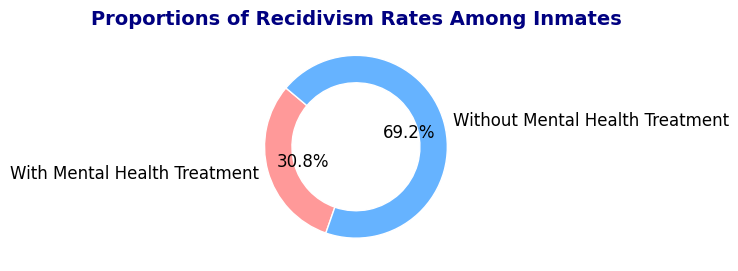Which group has a higher recidivism rate? The pie chart shows two groups: "With Mental Health Treatment" and "Without Mental Health Treatment." The group "Without Mental Health Treatment" has a larger slice of the pie chart, indicating a higher recidivism rate.
Answer: "Without Mental Health Treatment" What is the recidivism rate for inmates with mental health treatment? According to the pie chart, the label for the group "With Mental Health Treatment" includes the recidivism rate percentage displayed on the chart as 20%.
Answer: 20% What is the difference in recidivism rates between inmates with and without mental health treatment? The recidivism rate for those without treatment is 45%, and the rate for those with treatment is 20%. The difference can be calculated as 45% - 20%.
Answer: 25% What proportion of the total recidivism rate do inmates without mental health treatment represent? The chart shows that inmates without mental health treatment account for 45% of the total recidivism rates by the size of their slice in the pie chart.
Answer: 45% Which color represents the group with the highest recidivism rate? The group "Without Mental Health Treatment" has the highest recidivism rate, and its slice in the pie chart is colored blue.
Answer: Blue By what factor is the recidivism rate higher for inmates without mental health treatment compared to those who received treatment? To find the factor, divide the higher recidivism rate by the lower one: 45% / 20%.
Answer: 2.25 What fraction of recidivism rates does the group with mental health treatment represent? The pie chart shows that inmates with mental health treatment represent 20% of the total, which as a fraction is 20/100 or 1/5.
Answer: 1/5 How do the areas of the slices compare visually between the two groups? The pie chart's "Without Mental Health Treatment" slice is more than twice the size of the "With Mental Health Treatment" slice, underscoring a significant difference in recidivism rates.
Answer: More than twice What percentage of the total does the smaller slice represent? In the pie chart, the smaller slice representing "With Mental Health Treatment" is labeled as 20%.
Answer: 20% What is the combined recidivism rate for all inmates based on the pie chart? Adding both recidivism rates: 45% + 20% gives the combined rate.
Answer: 65% 